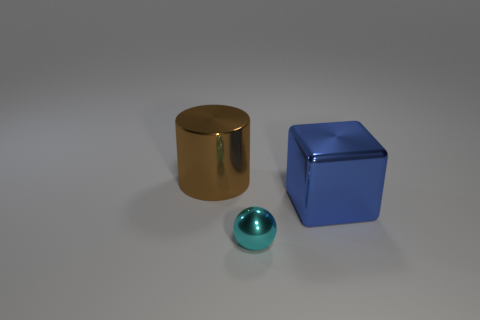Is the number of metal objects that are behind the cyan sphere greater than the number of blue blocks in front of the metallic cylinder?
Keep it short and to the point. Yes. What number of cylinders are either large cyan rubber objects or tiny metallic things?
Keep it short and to the point. 0. There is a big shiny thing right of the large metallic object behind the large blue metal thing; how many small cyan balls are on the left side of it?
Your answer should be very brief. 1. Is the number of large brown shiny cylinders greater than the number of metal objects?
Make the answer very short. No. Is the size of the cyan metallic thing the same as the block?
Ensure brevity in your answer.  No. How many things are either blue shiny cubes or small brown matte blocks?
Make the answer very short. 1. What shape is the big thing behind the big shiny thing in front of the big thing to the left of the shiny block?
Your response must be concise. Cylinder. Do the large blue cube to the right of the cyan ball and the large object left of the cube have the same material?
Provide a short and direct response. Yes. Are there any other things that have the same size as the cyan ball?
Offer a terse response. No. Does the big metal object to the right of the tiny metal sphere have the same shape as the large object to the left of the sphere?
Give a very brief answer. No. 